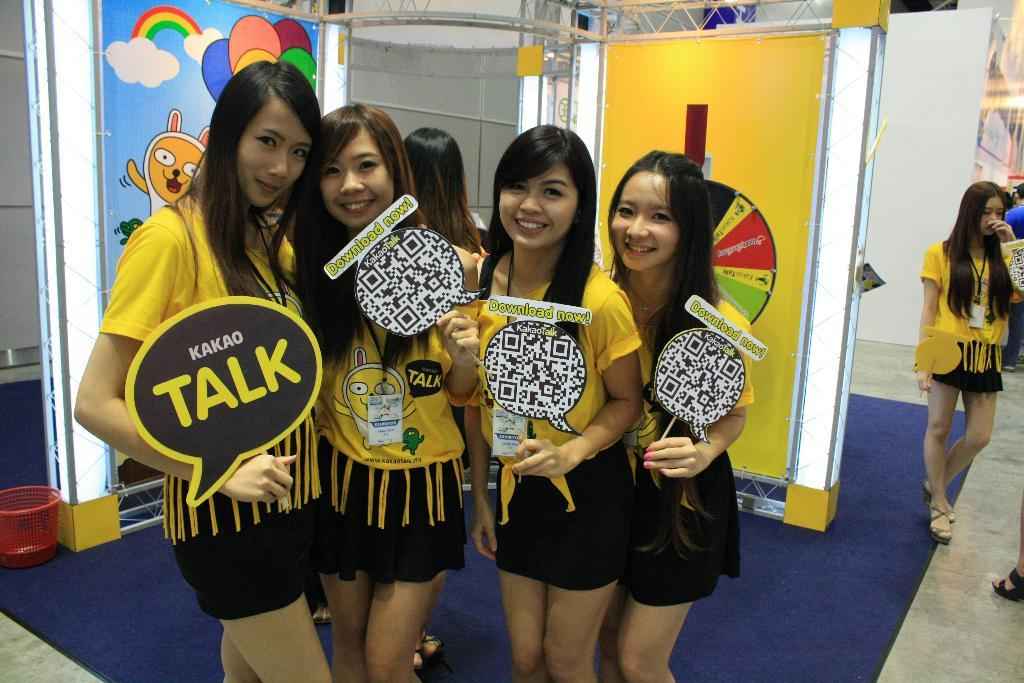Provide a one-sentence caption for the provided image. Four girls dressed in yellow and black with four signs in front of them with one of the sign has the word talk on it. 